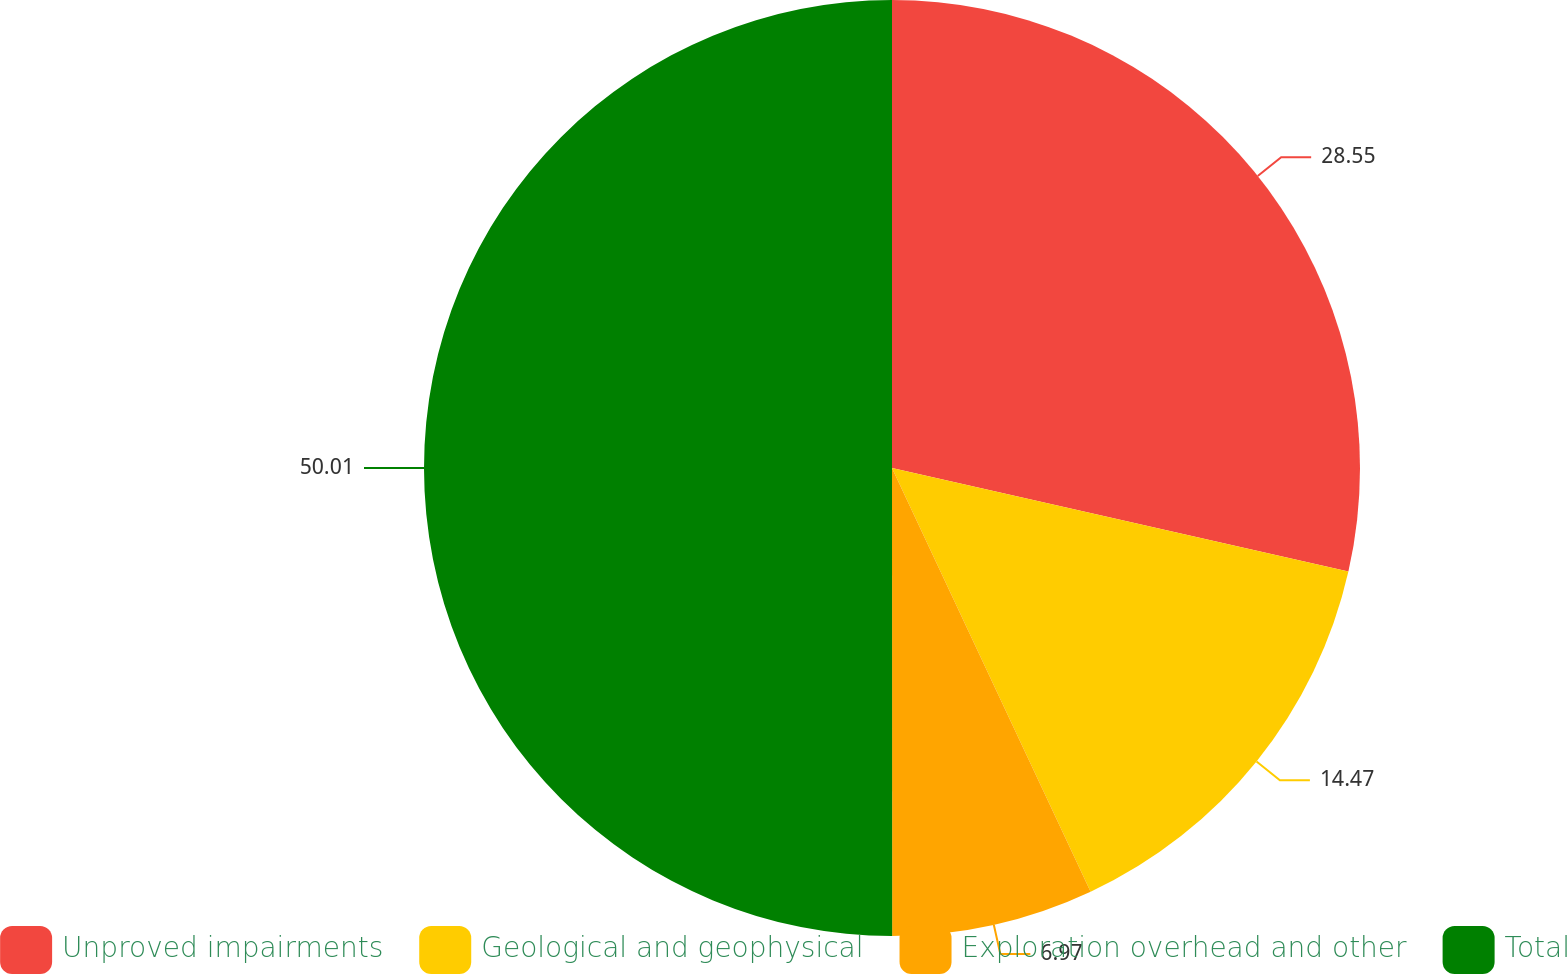Convert chart to OTSL. <chart><loc_0><loc_0><loc_500><loc_500><pie_chart><fcel>Unproved impairments<fcel>Geological and geophysical<fcel>Exploration overhead and other<fcel>Total<nl><fcel>28.55%<fcel>14.47%<fcel>6.97%<fcel>50.0%<nl></chart> 